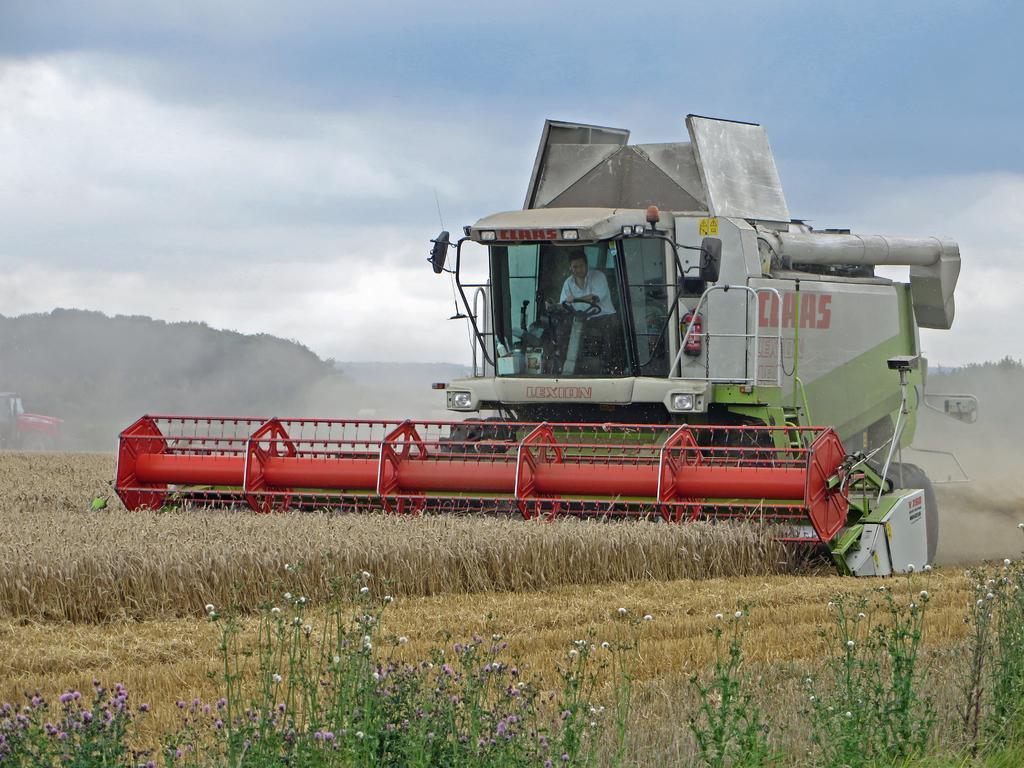What is the main subject of the image? The main subject of the image is a harvester. What is the harvester doing in the image? The harvester is cutting grass in the image. What can be seen in the background of the image? There are hills in the background of the image. What type of vegetation is present on the ground? Flower plants are present on the ground. What is visible at the top of the image? The sky is visible at the top of the image. Can you tell me where the kitty is playing in the image? There is no kitty present in the image. What type of amusement can be seen in the image? There is no amusement park or ride present in the image; it features a harvester cutting grass. 